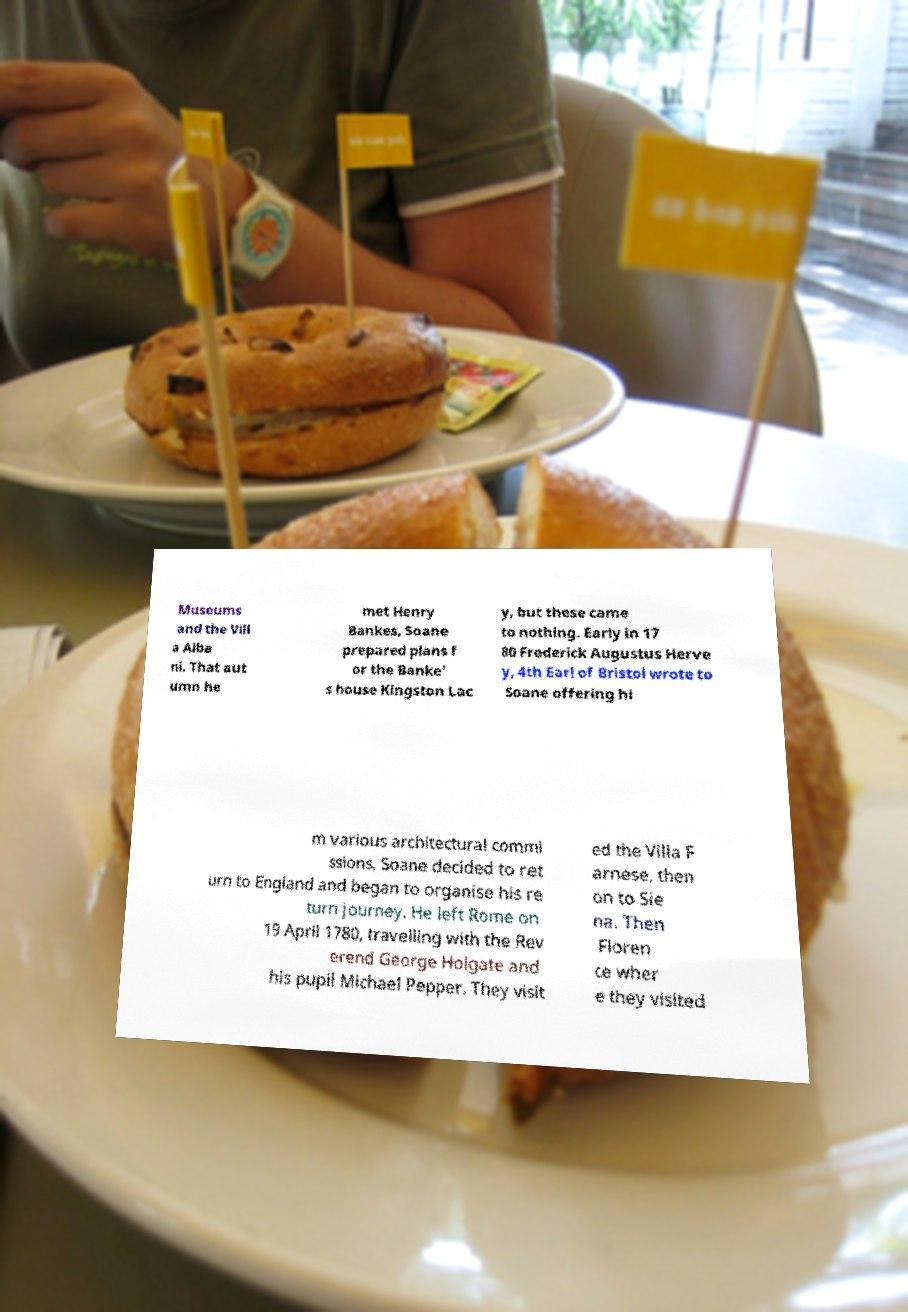Can you read and provide the text displayed in the image?This photo seems to have some interesting text. Can you extract and type it out for me? Museums and the Vill a Alba ni. That aut umn he met Henry Bankes, Soane prepared plans f or the Banke' s house Kingston Lac y, but these came to nothing. Early in 17 80 Frederick Augustus Herve y, 4th Earl of Bristol wrote to Soane offering hi m various architectural commi ssions, Soane decided to ret urn to England and began to organise his re turn journey. He left Rome on 19 April 1780, travelling with the Rev erend George Holgate and his pupil Michael Pepper. They visit ed the Villa F arnese, then on to Sie na. Then Floren ce wher e they visited 